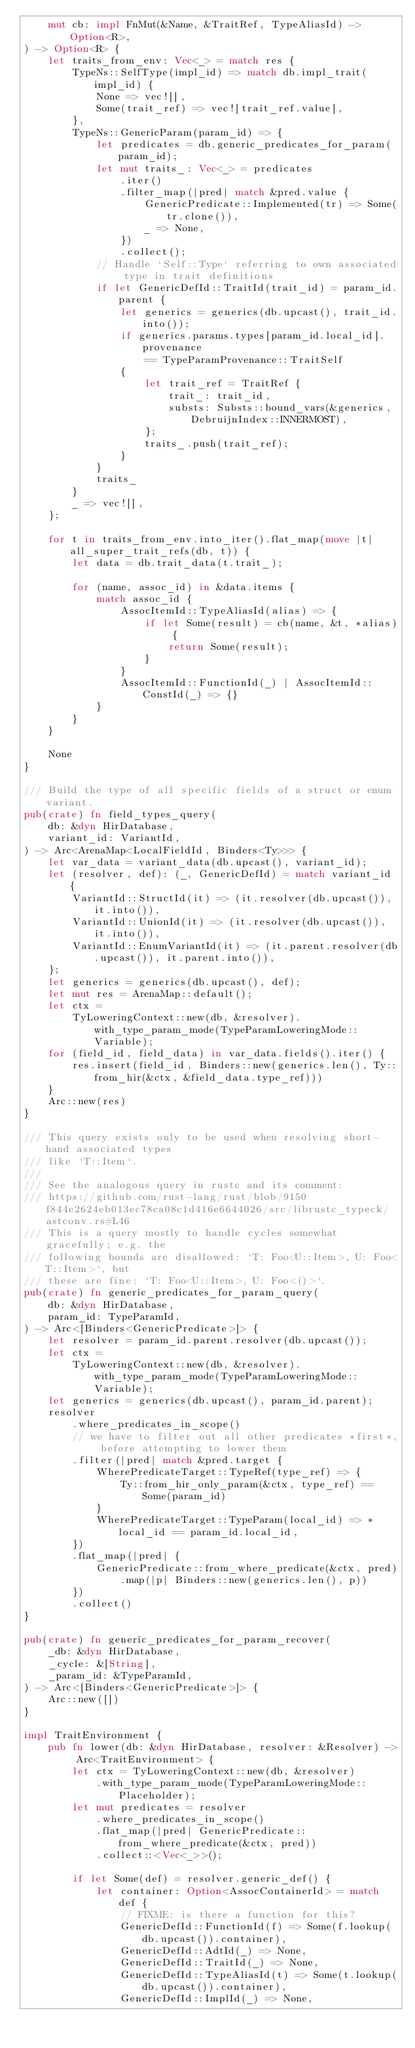Convert code to text. <code><loc_0><loc_0><loc_500><loc_500><_Rust_>    mut cb: impl FnMut(&Name, &TraitRef, TypeAliasId) -> Option<R>,
) -> Option<R> {
    let traits_from_env: Vec<_> = match res {
        TypeNs::SelfType(impl_id) => match db.impl_trait(impl_id) {
            None => vec![],
            Some(trait_ref) => vec![trait_ref.value],
        },
        TypeNs::GenericParam(param_id) => {
            let predicates = db.generic_predicates_for_param(param_id);
            let mut traits_: Vec<_> = predicates
                .iter()
                .filter_map(|pred| match &pred.value {
                    GenericPredicate::Implemented(tr) => Some(tr.clone()),
                    _ => None,
                })
                .collect();
            // Handle `Self::Type` referring to own associated type in trait definitions
            if let GenericDefId::TraitId(trait_id) = param_id.parent {
                let generics = generics(db.upcast(), trait_id.into());
                if generics.params.types[param_id.local_id].provenance
                    == TypeParamProvenance::TraitSelf
                {
                    let trait_ref = TraitRef {
                        trait_: trait_id,
                        substs: Substs::bound_vars(&generics, DebruijnIndex::INNERMOST),
                    };
                    traits_.push(trait_ref);
                }
            }
            traits_
        }
        _ => vec![],
    };

    for t in traits_from_env.into_iter().flat_map(move |t| all_super_trait_refs(db, t)) {
        let data = db.trait_data(t.trait_);

        for (name, assoc_id) in &data.items {
            match assoc_id {
                AssocItemId::TypeAliasId(alias) => {
                    if let Some(result) = cb(name, &t, *alias) {
                        return Some(result);
                    }
                }
                AssocItemId::FunctionId(_) | AssocItemId::ConstId(_) => {}
            }
        }
    }

    None
}

/// Build the type of all specific fields of a struct or enum variant.
pub(crate) fn field_types_query(
    db: &dyn HirDatabase,
    variant_id: VariantId,
) -> Arc<ArenaMap<LocalFieldId, Binders<Ty>>> {
    let var_data = variant_data(db.upcast(), variant_id);
    let (resolver, def): (_, GenericDefId) = match variant_id {
        VariantId::StructId(it) => (it.resolver(db.upcast()), it.into()),
        VariantId::UnionId(it) => (it.resolver(db.upcast()), it.into()),
        VariantId::EnumVariantId(it) => (it.parent.resolver(db.upcast()), it.parent.into()),
    };
    let generics = generics(db.upcast(), def);
    let mut res = ArenaMap::default();
    let ctx =
        TyLoweringContext::new(db, &resolver).with_type_param_mode(TypeParamLoweringMode::Variable);
    for (field_id, field_data) in var_data.fields().iter() {
        res.insert(field_id, Binders::new(generics.len(), Ty::from_hir(&ctx, &field_data.type_ref)))
    }
    Arc::new(res)
}

/// This query exists only to be used when resolving short-hand associated types
/// like `T::Item`.
///
/// See the analogous query in rustc and its comment:
/// https://github.com/rust-lang/rust/blob/9150f844e2624eb013ec78ca08c1d416e6644026/src/librustc_typeck/astconv.rs#L46
/// This is a query mostly to handle cycles somewhat gracefully; e.g. the
/// following bounds are disallowed: `T: Foo<U::Item>, U: Foo<T::Item>`, but
/// these are fine: `T: Foo<U::Item>, U: Foo<()>`.
pub(crate) fn generic_predicates_for_param_query(
    db: &dyn HirDatabase,
    param_id: TypeParamId,
) -> Arc<[Binders<GenericPredicate>]> {
    let resolver = param_id.parent.resolver(db.upcast());
    let ctx =
        TyLoweringContext::new(db, &resolver).with_type_param_mode(TypeParamLoweringMode::Variable);
    let generics = generics(db.upcast(), param_id.parent);
    resolver
        .where_predicates_in_scope()
        // we have to filter out all other predicates *first*, before attempting to lower them
        .filter(|pred| match &pred.target {
            WherePredicateTarget::TypeRef(type_ref) => {
                Ty::from_hir_only_param(&ctx, type_ref) == Some(param_id)
            }
            WherePredicateTarget::TypeParam(local_id) => *local_id == param_id.local_id,
        })
        .flat_map(|pred| {
            GenericPredicate::from_where_predicate(&ctx, pred)
                .map(|p| Binders::new(generics.len(), p))
        })
        .collect()
}

pub(crate) fn generic_predicates_for_param_recover(
    _db: &dyn HirDatabase,
    _cycle: &[String],
    _param_id: &TypeParamId,
) -> Arc<[Binders<GenericPredicate>]> {
    Arc::new([])
}

impl TraitEnvironment {
    pub fn lower(db: &dyn HirDatabase, resolver: &Resolver) -> Arc<TraitEnvironment> {
        let ctx = TyLoweringContext::new(db, &resolver)
            .with_type_param_mode(TypeParamLoweringMode::Placeholder);
        let mut predicates = resolver
            .where_predicates_in_scope()
            .flat_map(|pred| GenericPredicate::from_where_predicate(&ctx, pred))
            .collect::<Vec<_>>();

        if let Some(def) = resolver.generic_def() {
            let container: Option<AssocContainerId> = match def {
                // FIXME: is there a function for this?
                GenericDefId::FunctionId(f) => Some(f.lookup(db.upcast()).container),
                GenericDefId::AdtId(_) => None,
                GenericDefId::TraitId(_) => None,
                GenericDefId::TypeAliasId(t) => Some(t.lookup(db.upcast()).container),
                GenericDefId::ImplId(_) => None,</code> 